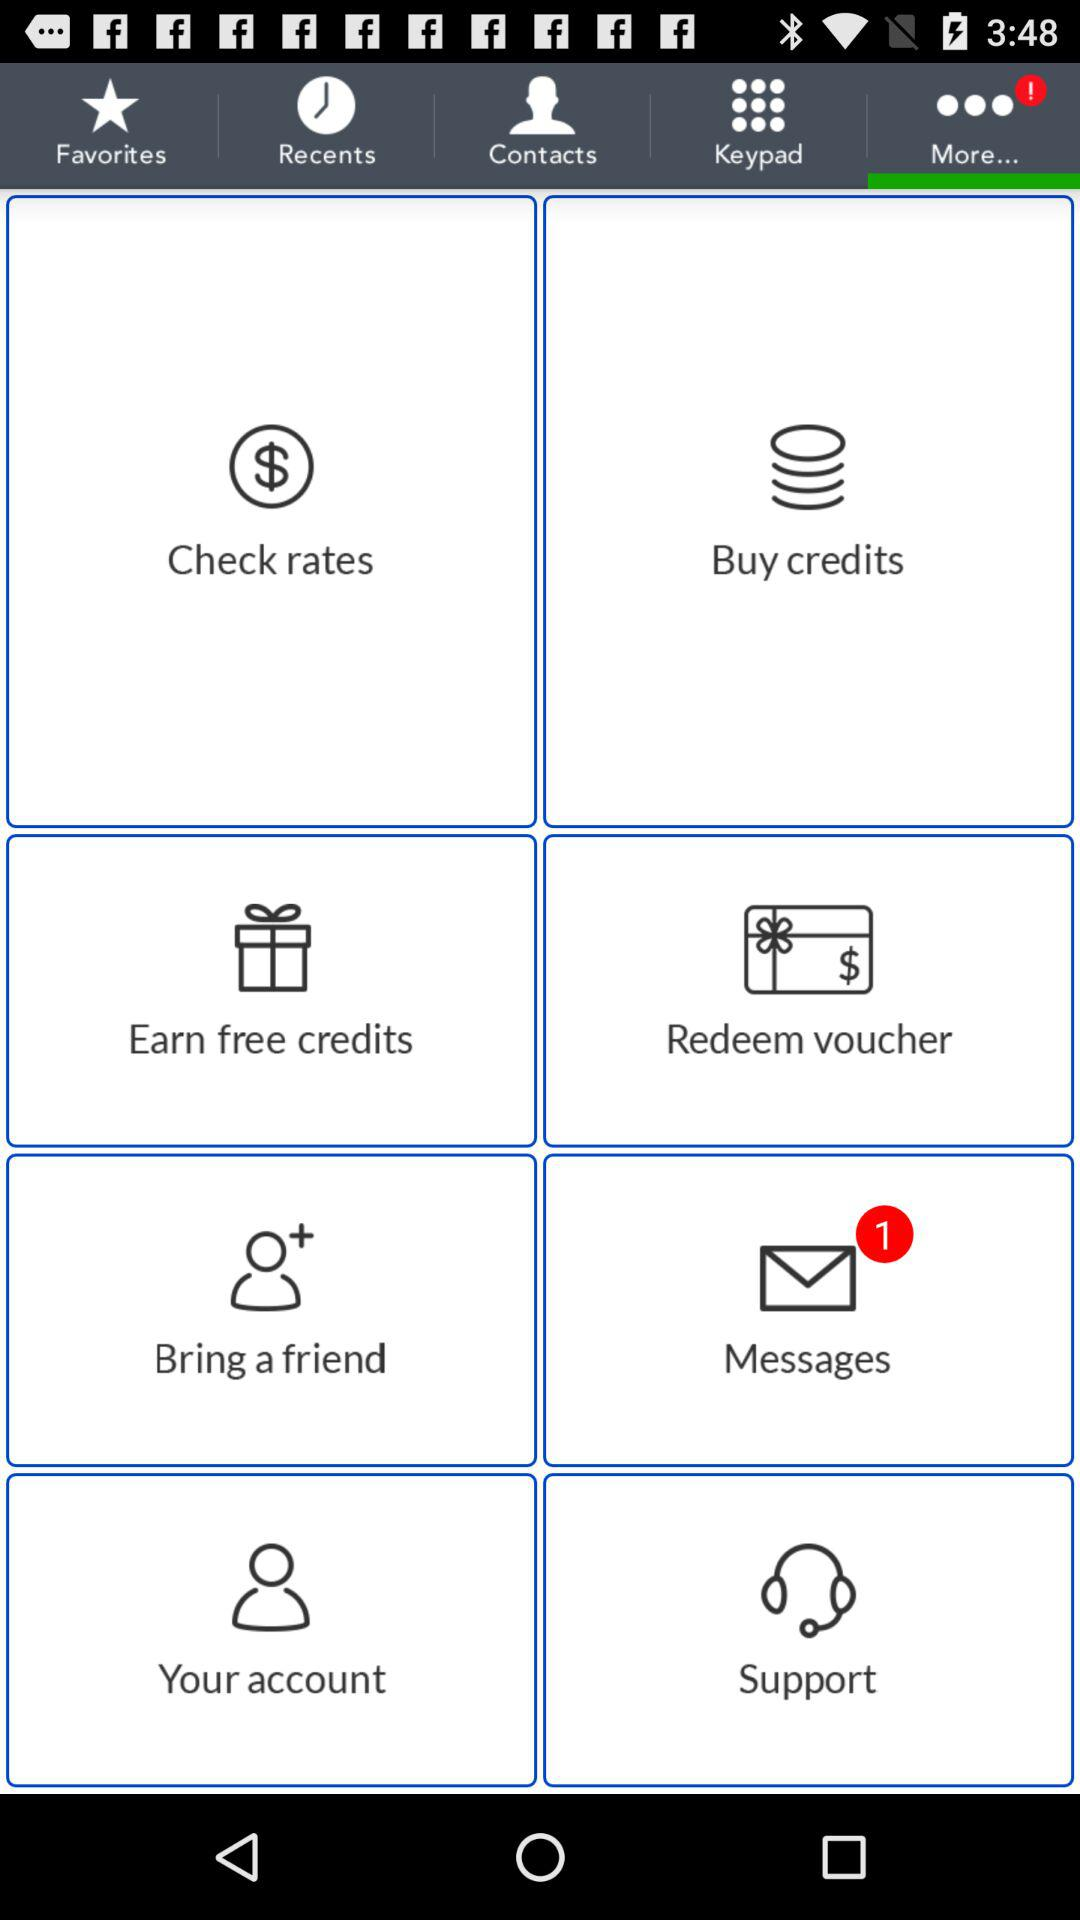How many new contacts are there?
When the provided information is insufficient, respond with <no answer>. <no answer> 